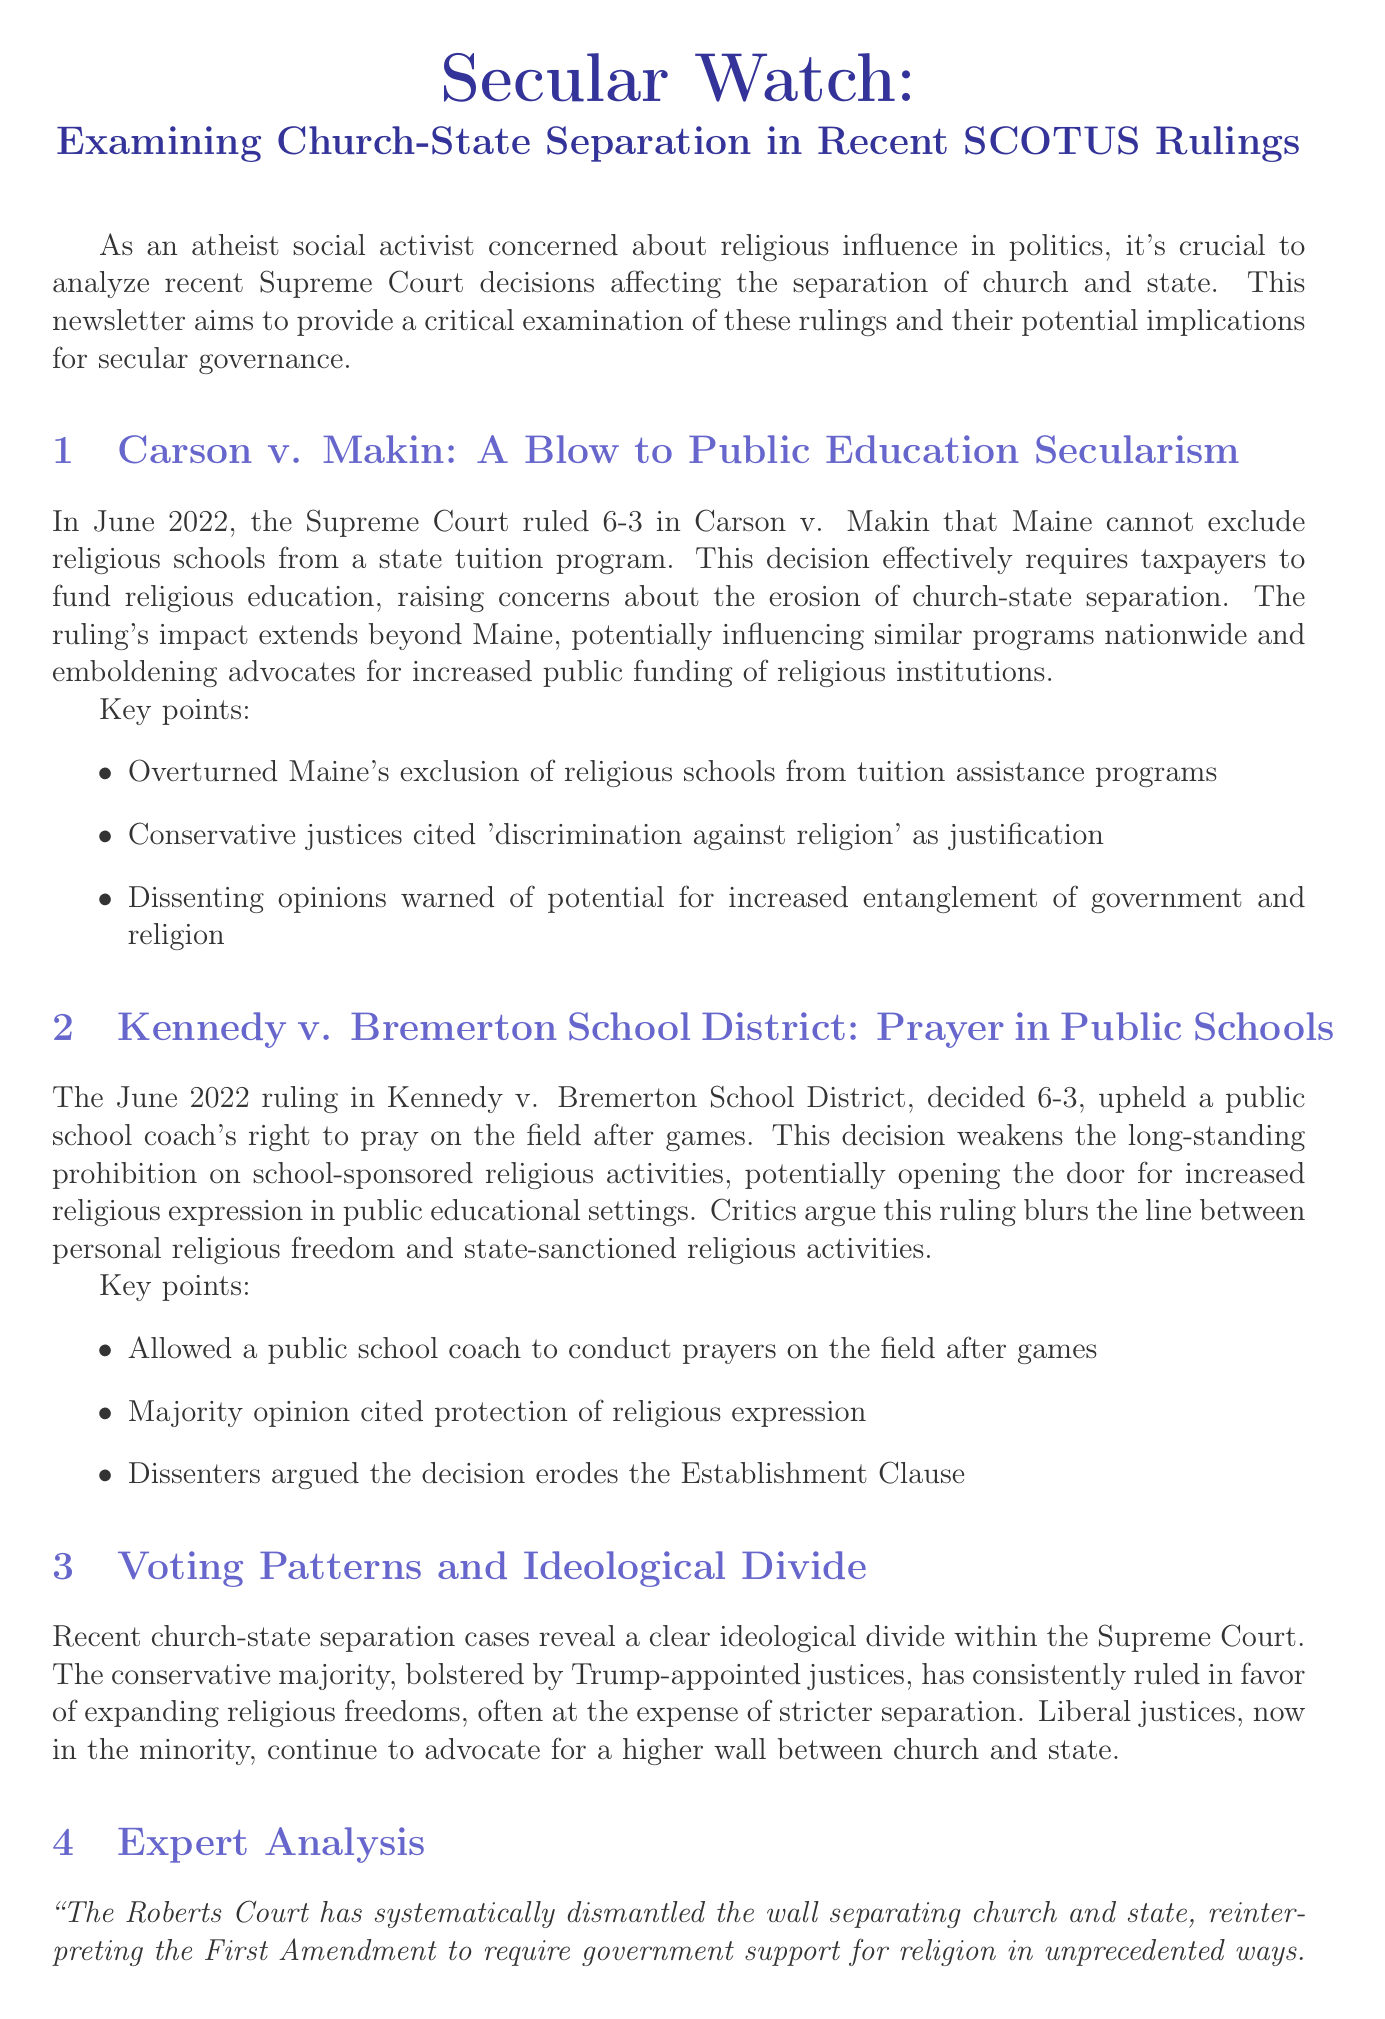What was the ruling date for Carson v. Makin? The ruling date is mentioned in the newsletter, which states it was in June 2022.
Answer: June 2022 How many justices ruled in favor of Carson v. Makin? The newsletter indicates that the ruling passed with a 6-3 majority.
Answer: 6 What issue did Kennedy v. Bremerton School District address? The issue is highlighted in the newsletter as a public school coach's right to pray on the field.
Answer: Prayer What do conservative justices argue in church-state separation cases? The newsletter notes that they often cite 'discrimination against religion' as justification for their rulings.
Answer: Discrimination against religion Who is the expert providing analysis in the newsletter? The document names Dr. Erwin Chemerinsky as the expert giving an analysis.
Answer: Dr. Erwin Chemerinsky Which organizations are suggested for support in defending secular governance? The newsletter recommends organizations like the Freedom From Religion Foundation and the American Humanist Association.
Answer: Freedom From Religion Foundation and American Humanist Association What trend is indicated by the voting patterns of conservative justices? The document suggests that there is a consistent pattern of conservative justices voting together in favor of expanded religious freedoms.
Answer: Consistent voting together What is the publication year of the article by Stephanie H. Barclay? The document provides the publication year as 2022.
Answer: 2022 